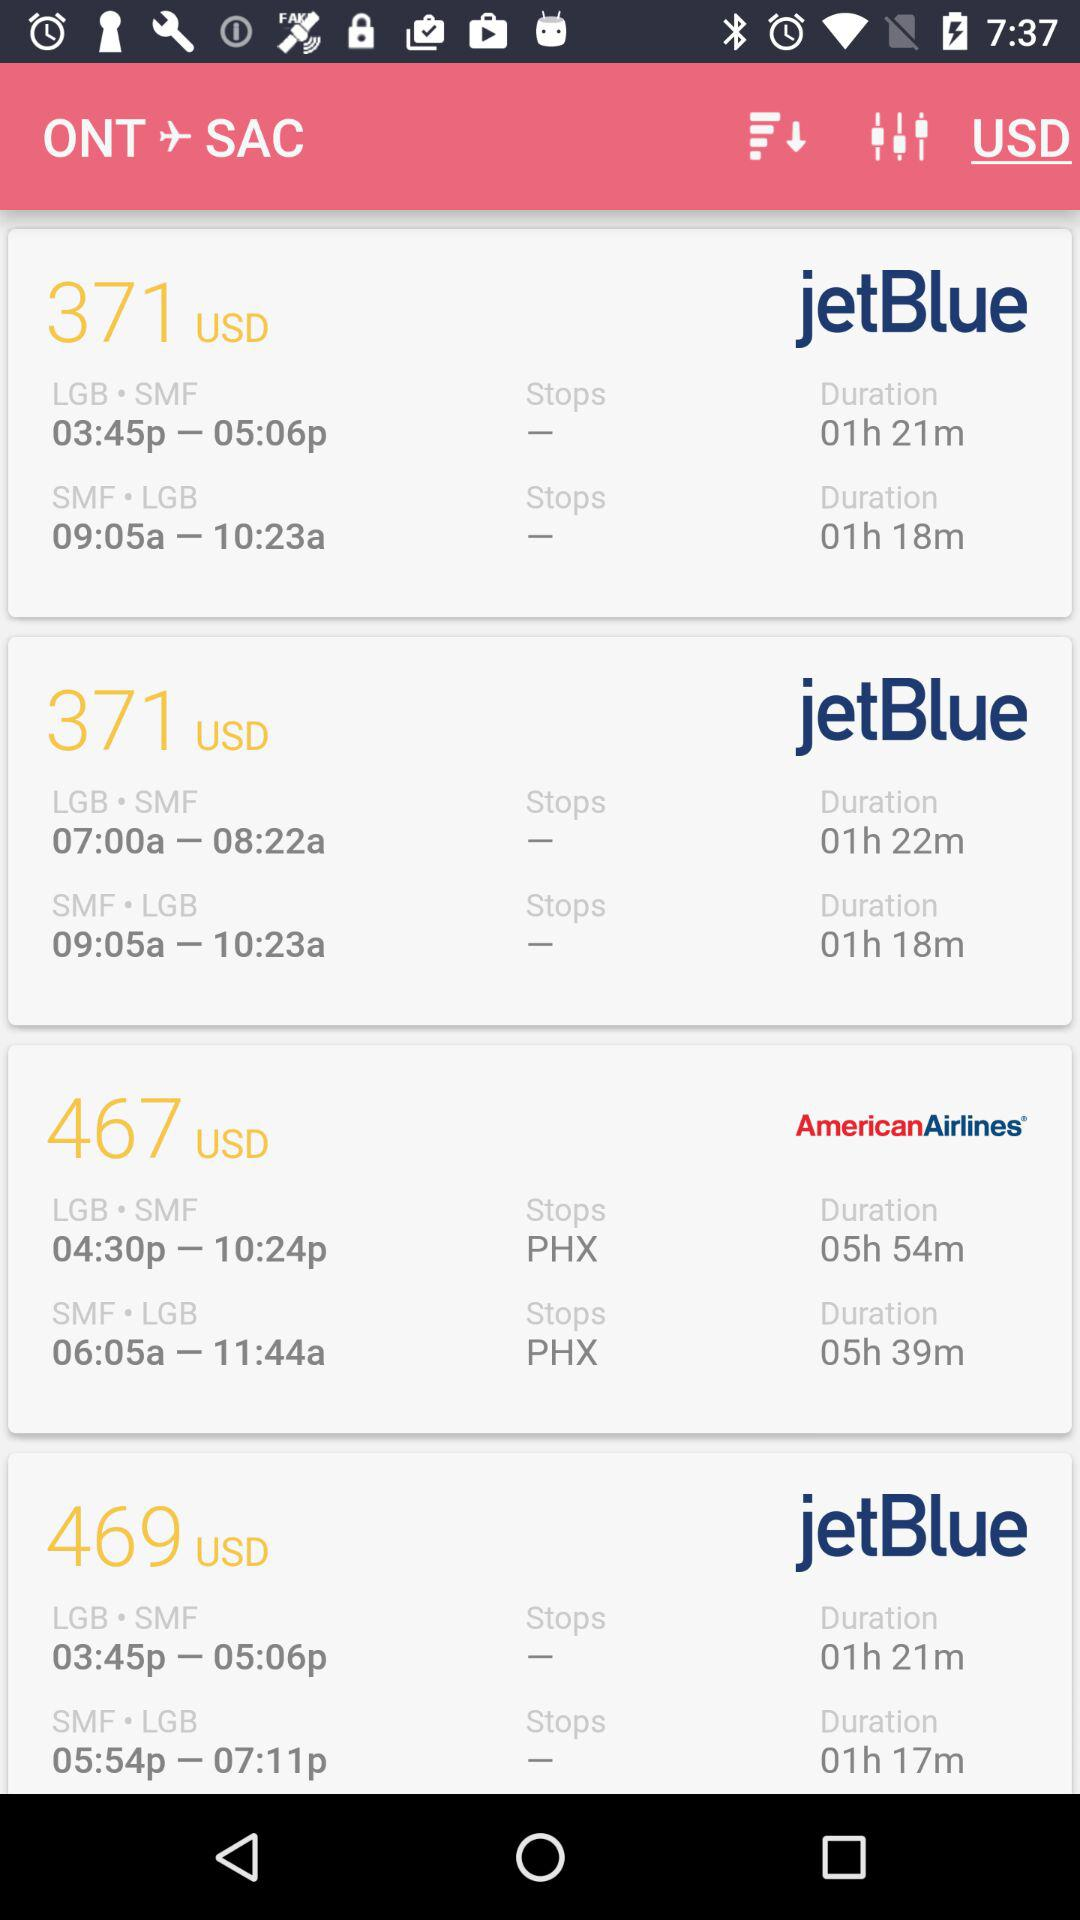How many more stops does the first flight have?
Answer the question using a single word or phrase. 1 